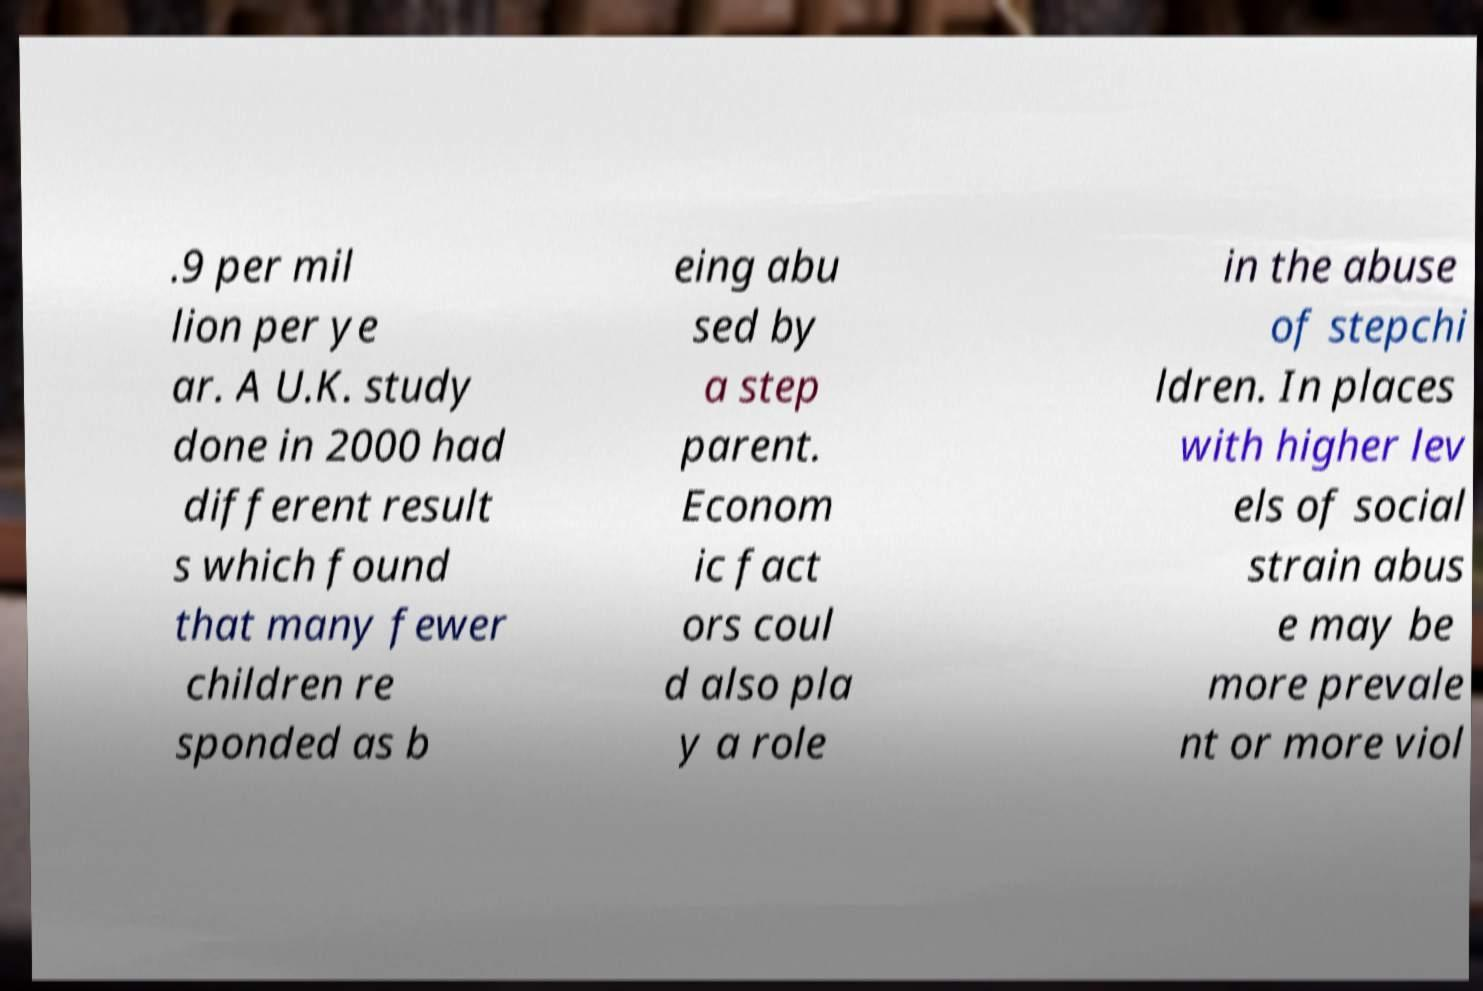Can you read and provide the text displayed in the image?This photo seems to have some interesting text. Can you extract and type it out for me? .9 per mil lion per ye ar. A U.K. study done in 2000 had different result s which found that many fewer children re sponded as b eing abu sed by a step parent. Econom ic fact ors coul d also pla y a role in the abuse of stepchi ldren. In places with higher lev els of social strain abus e may be more prevale nt or more viol 